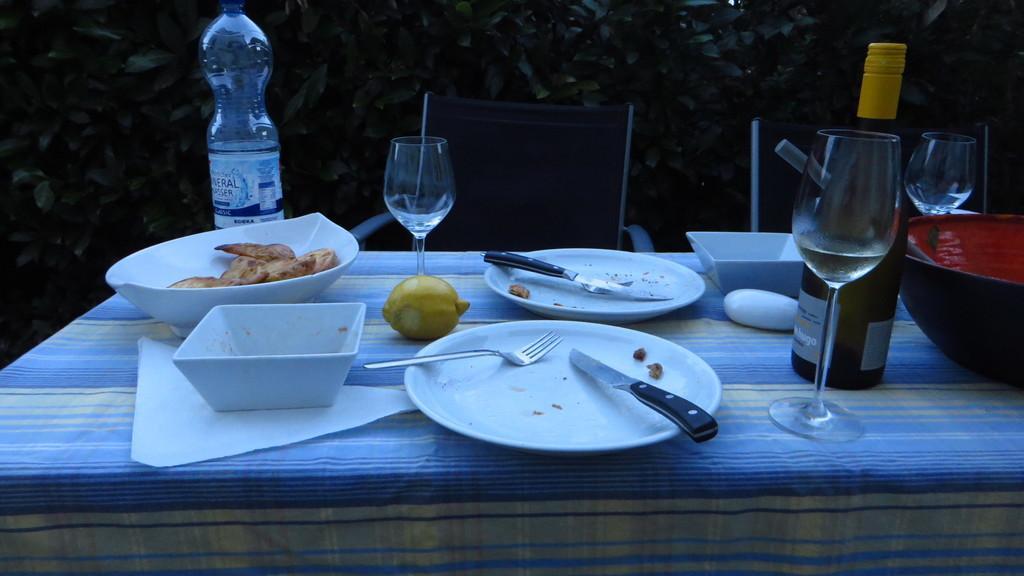Could you give a brief overview of what you see in this image? This is a table covered with a cloth. These are the plates,bowls,wine glasses,water bottle,wine bottle and few other things placed on the table. These are the chairs. At background I can see trees. 